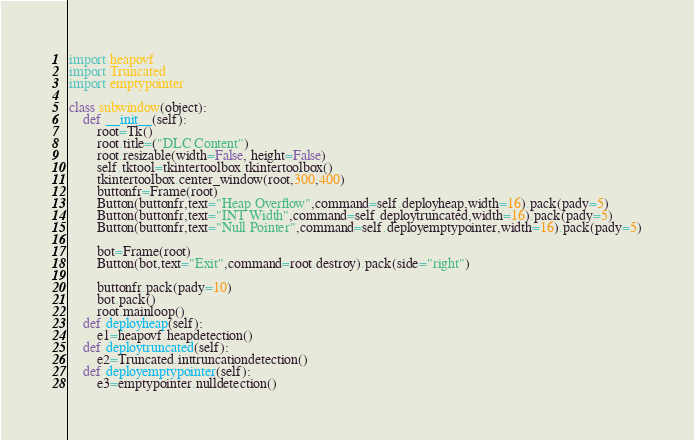Convert code to text. <code><loc_0><loc_0><loc_500><loc_500><_Python_>
import heapovf
import Truncated
import emptypointer

class subwindow(object):
    def __init__(self):
        root=Tk()
        root.title=("DLC Content")
        root.resizable(width=False, height=False)
        self.tktool=tkintertoolbox.tkintertoolbox()
        tkintertoolbox.center_window(root,300,400)
        buttonfr=Frame(root)
        Button(buttonfr,text="Heap Overflow",command=self.deployheap,width=16).pack(pady=5)
        Button(buttonfr,text="INT Width",command=self.deploytruncated,width=16).pack(pady=5)
        Button(buttonfr,text="Null Pointer",command=self.deployemptypointer,width=16).pack(pady=5)

        bot=Frame(root)
        Button(bot,text="Exit",command=root.destroy).pack(side="right")

        buttonfr.pack(pady=10)
        bot.pack()
        root.mainloop()
    def deployheap(self):
        e1=heapovf.heapdetection()
    def deploytruncated(self):
        e2=Truncated.inttruncationdetection()
    def deployemptypointer(self):
        e3=emptypointer.nulldetection()
</code> 